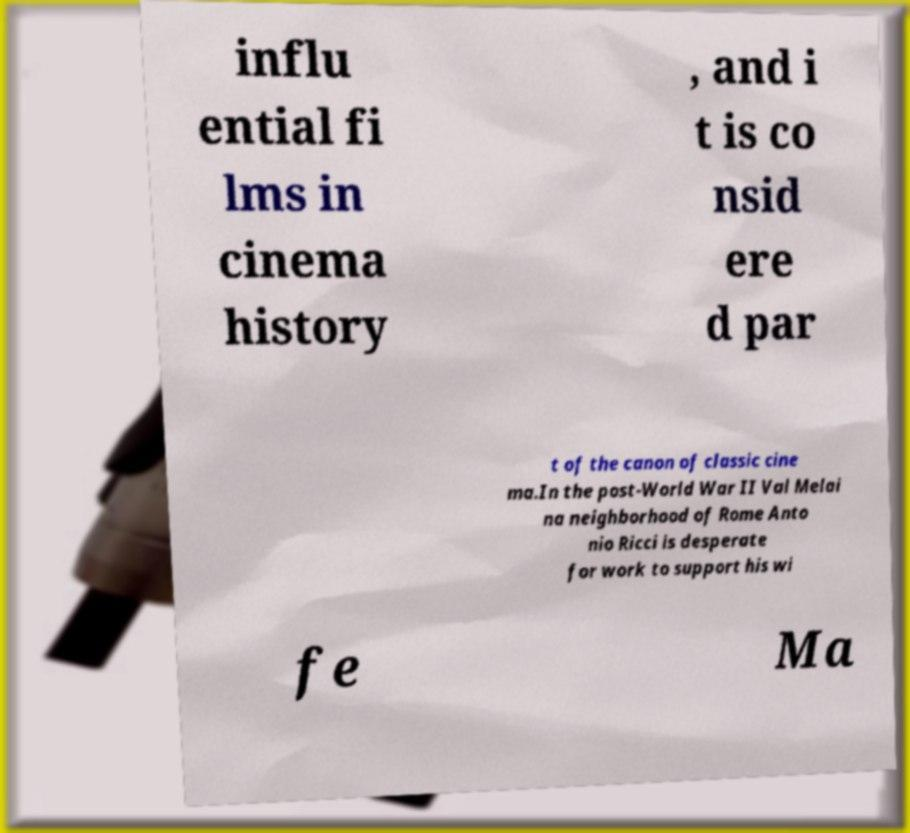Can you read and provide the text displayed in the image?This photo seems to have some interesting text. Can you extract and type it out for me? influ ential fi lms in cinema history , and i t is co nsid ere d par t of the canon of classic cine ma.In the post-World War II Val Melai na neighborhood of Rome Anto nio Ricci is desperate for work to support his wi fe Ma 